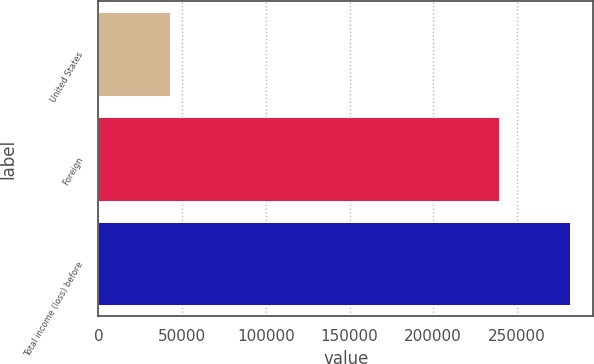Convert chart. <chart><loc_0><loc_0><loc_500><loc_500><bar_chart><fcel>United States<fcel>Foreign<fcel>Total income (loss) before<nl><fcel>42571<fcel>239039<fcel>281610<nl></chart> 